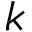Convert formula to latex. <formula><loc_0><loc_0><loc_500><loc_500>k</formula> 